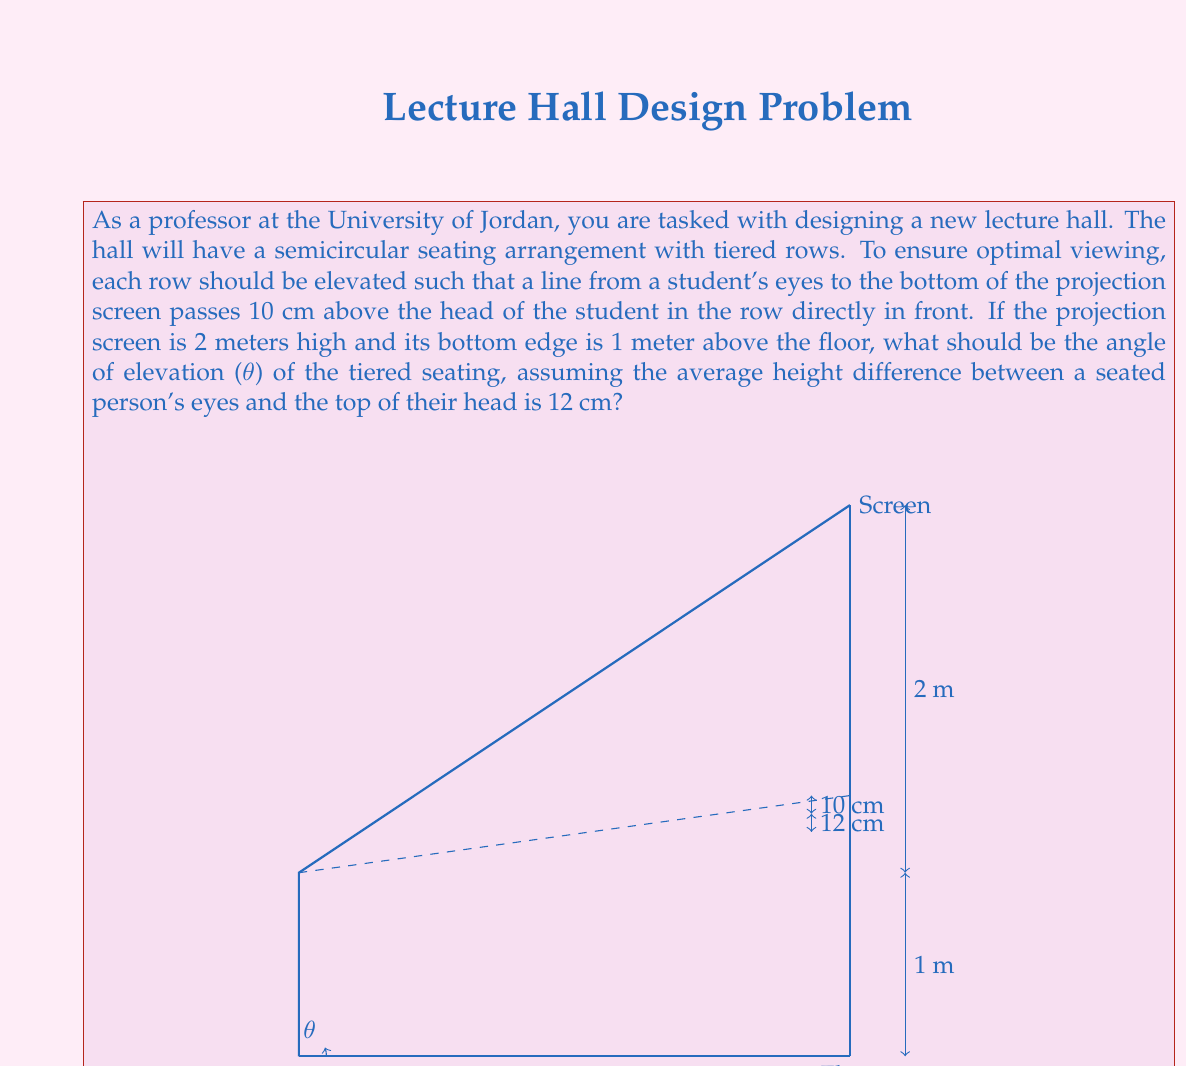What is the answer to this math problem? Let's approach this problem step by step:

1) First, we need to set up a right triangle that represents the viewing angle from one row to the next.

2) In this triangle:
   - The opposite side is the sum of the height difference (10 cm) and the eye-to-head height (12 cm), which is 22 cm or 0.22 m.
   - The adjacent side is the horizontal distance between rows, which we don't know yet but can call $x$.

3) The tangent of the angle θ is the ratio of opposite to adjacent:

   $$ \tan(\theta) = \frac{0.22}{x} $$

4) Now, let's consider the larger triangle from the student's eyes to the bottom of the screen:
   - The opposite side is the height of the screen (2 m) plus the height from the floor (1 m), minus the seated eye height (let's estimate this as 1.2 m). So, 2 + 1 - 1.2 = 1.8 m.
   - The adjacent side is the total horizontal distance from the first row to the screen, which we can call $nx$, where $n$ is the number of rows.

5) This larger triangle has the same angle θ, so:

   $$ \tan(\theta) = \frac{1.8}{nx} $$

6) Since these are equal:

   $$ \frac{0.22}{x} = \frac{1.8}{nx} $$

7) Simplify:

   $$ 0.22n = 1.8 $$
   $$ n = \frac{1.8}{0.22} \approx 8.18 $$

8) This means that for every 8.18 row spaces, we rise 1.8 m.

9) We can now find θ:

   $$ \theta = \arctan(\frac{1.8}{8.18}) \approx 0.2167 \text{ radians} $$

10) Convert to degrees:

    $$ \theta \approx 0.2167 \times \frac{180}{\pi} \approx 12.42° $$
Answer: The angle of elevation (θ) for the tiered seating should be approximately $12.42°$. 